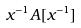<formula> <loc_0><loc_0><loc_500><loc_500>x ^ { - 1 } A [ x ^ { - 1 } ]</formula> 